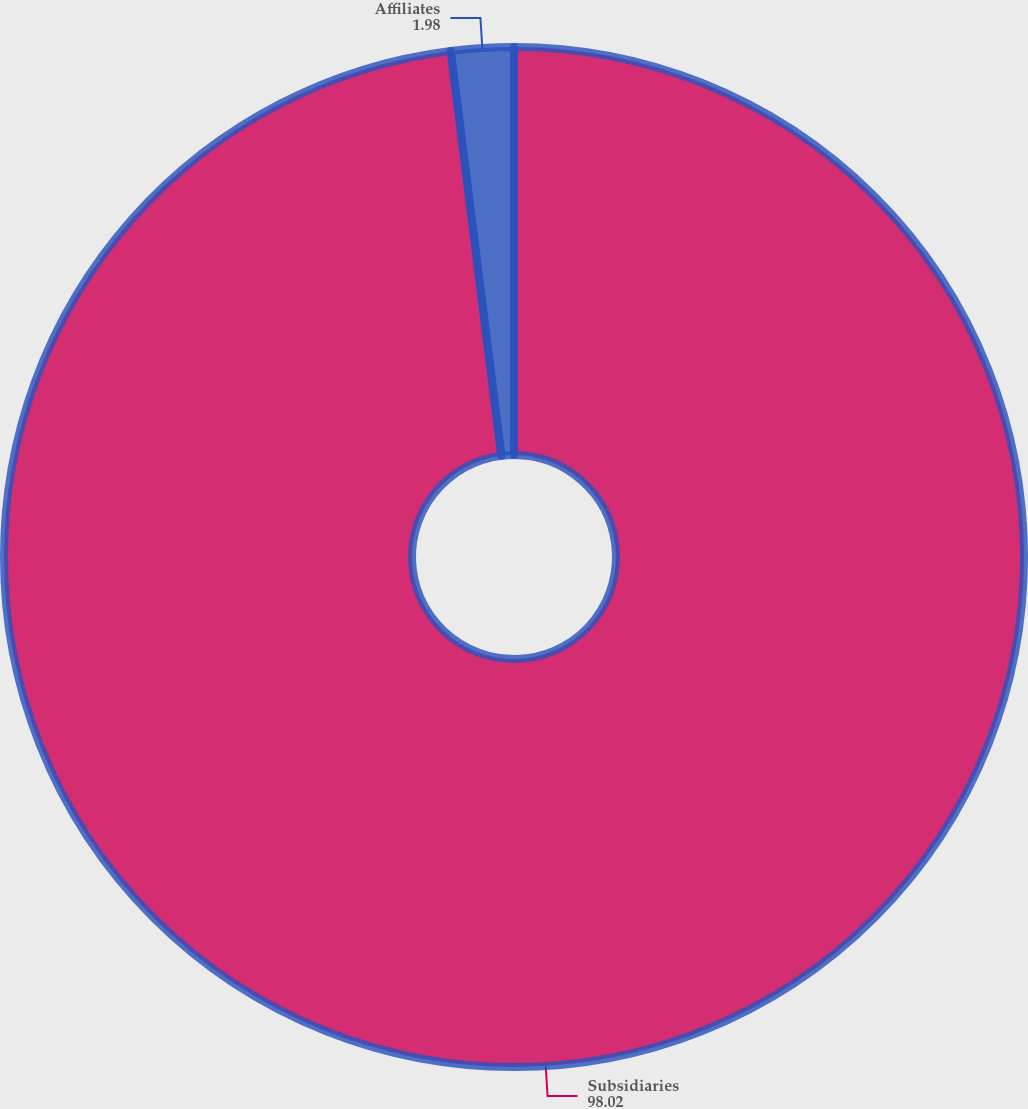Convert chart to OTSL. <chart><loc_0><loc_0><loc_500><loc_500><pie_chart><fcel>Subsidiaries<fcel>Affiliates<nl><fcel>98.02%<fcel>1.98%<nl></chart> 